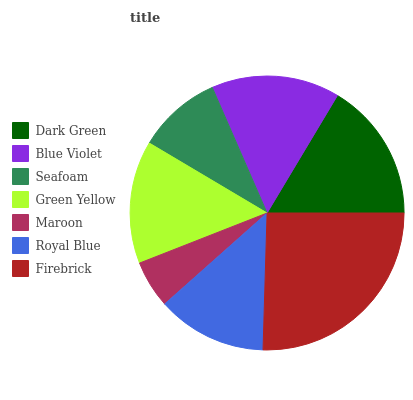Is Maroon the minimum?
Answer yes or no. Yes. Is Firebrick the maximum?
Answer yes or no. Yes. Is Blue Violet the minimum?
Answer yes or no. No. Is Blue Violet the maximum?
Answer yes or no. No. Is Dark Green greater than Blue Violet?
Answer yes or no. Yes. Is Blue Violet less than Dark Green?
Answer yes or no. Yes. Is Blue Violet greater than Dark Green?
Answer yes or no. No. Is Dark Green less than Blue Violet?
Answer yes or no. No. Is Green Yellow the high median?
Answer yes or no. Yes. Is Green Yellow the low median?
Answer yes or no. Yes. Is Royal Blue the high median?
Answer yes or no. No. Is Firebrick the low median?
Answer yes or no. No. 